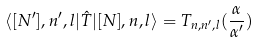<formula> <loc_0><loc_0><loc_500><loc_500>\langle [ N ^ { \prime } ] , n ^ { \prime } , l | \hat { T } | [ N ] , n , l \rangle = T _ { n , n ^ { \prime } , l } ( \frac { \alpha } { \alpha ^ { \prime } } )</formula> 